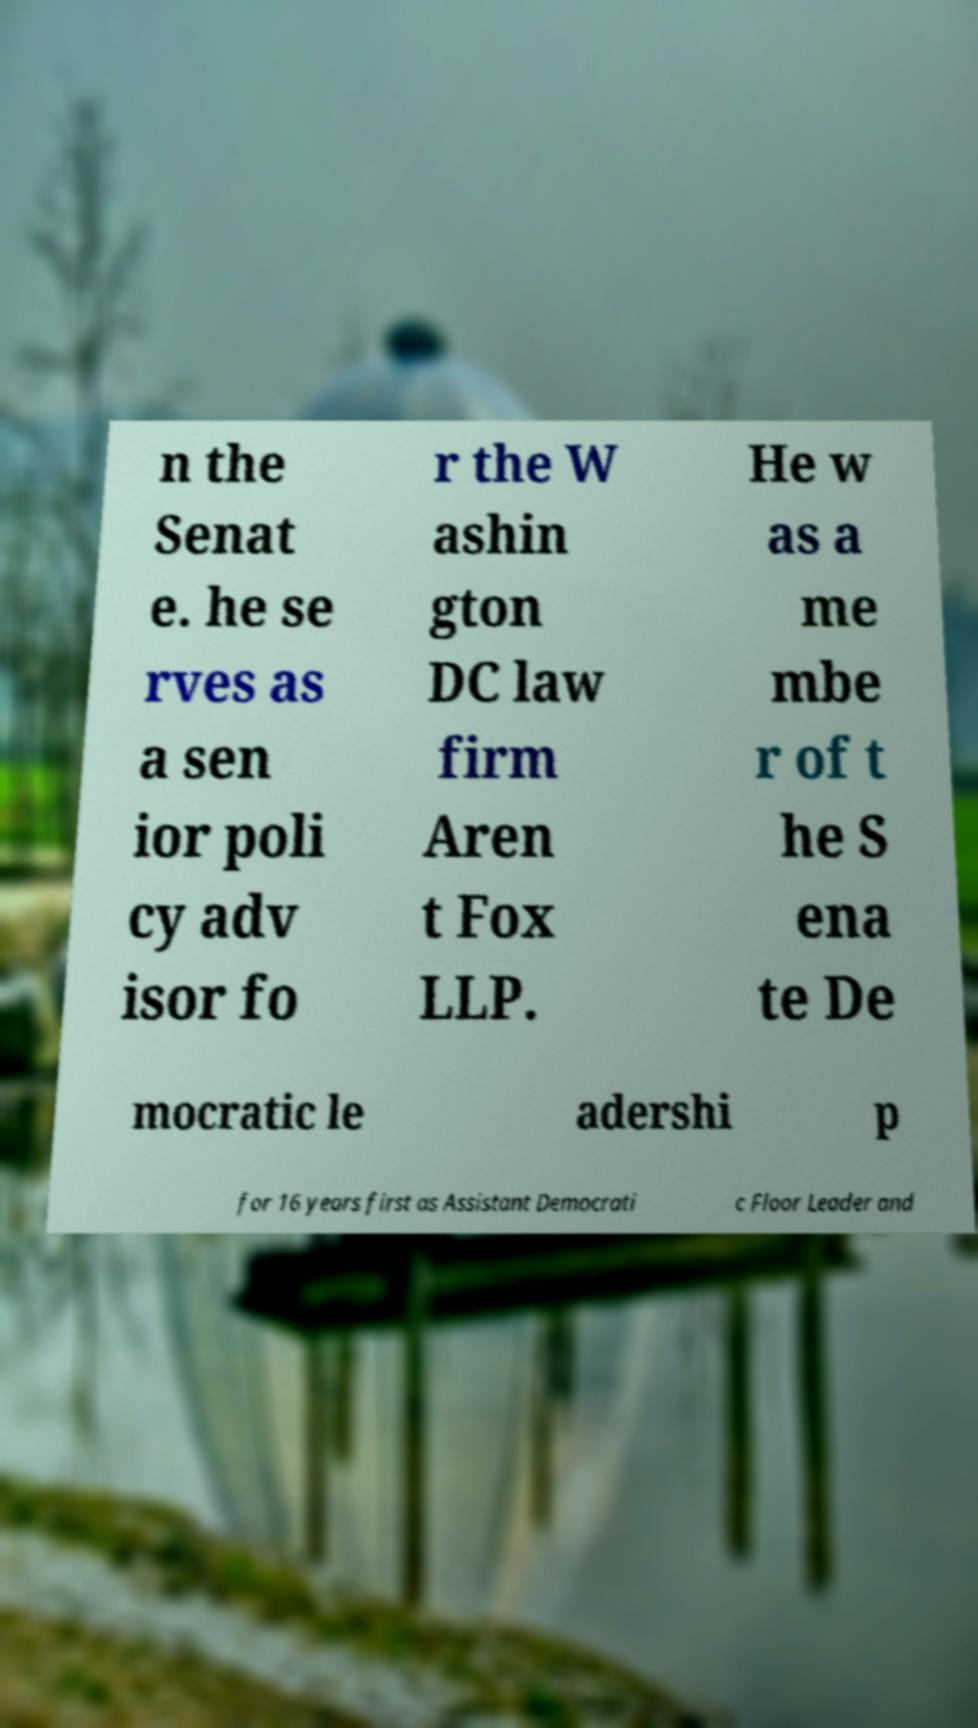Could you assist in decoding the text presented in this image and type it out clearly? n the Senat e. he se rves as a sen ior poli cy adv isor fo r the W ashin gton DC law firm Aren t Fox LLP. He w as a me mbe r of t he S ena te De mocratic le adershi p for 16 years first as Assistant Democrati c Floor Leader and 